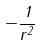<formula> <loc_0><loc_0><loc_500><loc_500>- \frac { 1 } { r ^ { 2 } }</formula> 